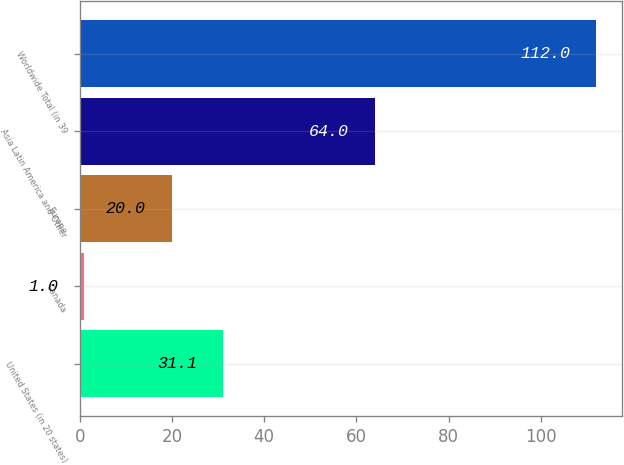Convert chart to OTSL. <chart><loc_0><loc_0><loc_500><loc_500><bar_chart><fcel>United States (in 20 states)<fcel>Canada<fcel>Europe<fcel>Asia Latin America and Other<fcel>Worldwide Total (in 39<nl><fcel>31.1<fcel>1<fcel>20<fcel>64<fcel>112<nl></chart> 